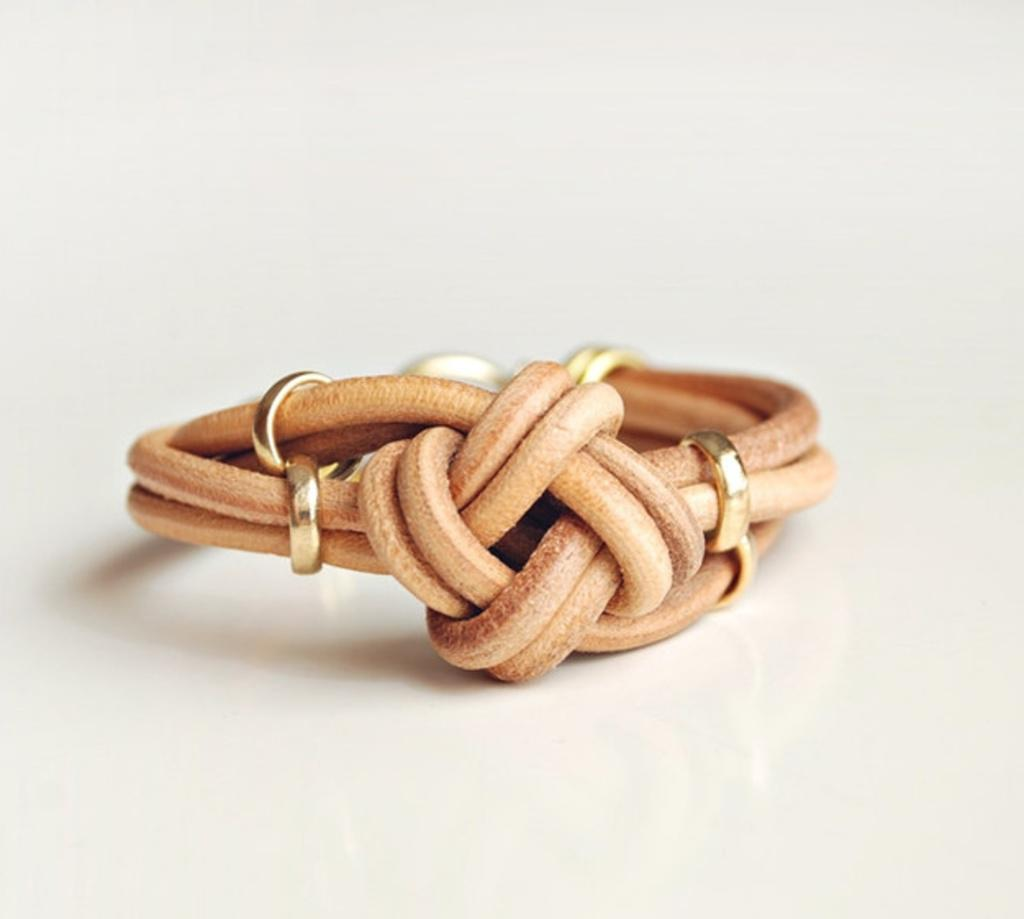What is the color of the main object in the image? The main object in the image is cream-colored. What color is the background of the image? The background of the image is white. What is the interest rate on the gold house in the image? There is no gold house or mention of interest rates in the image. 